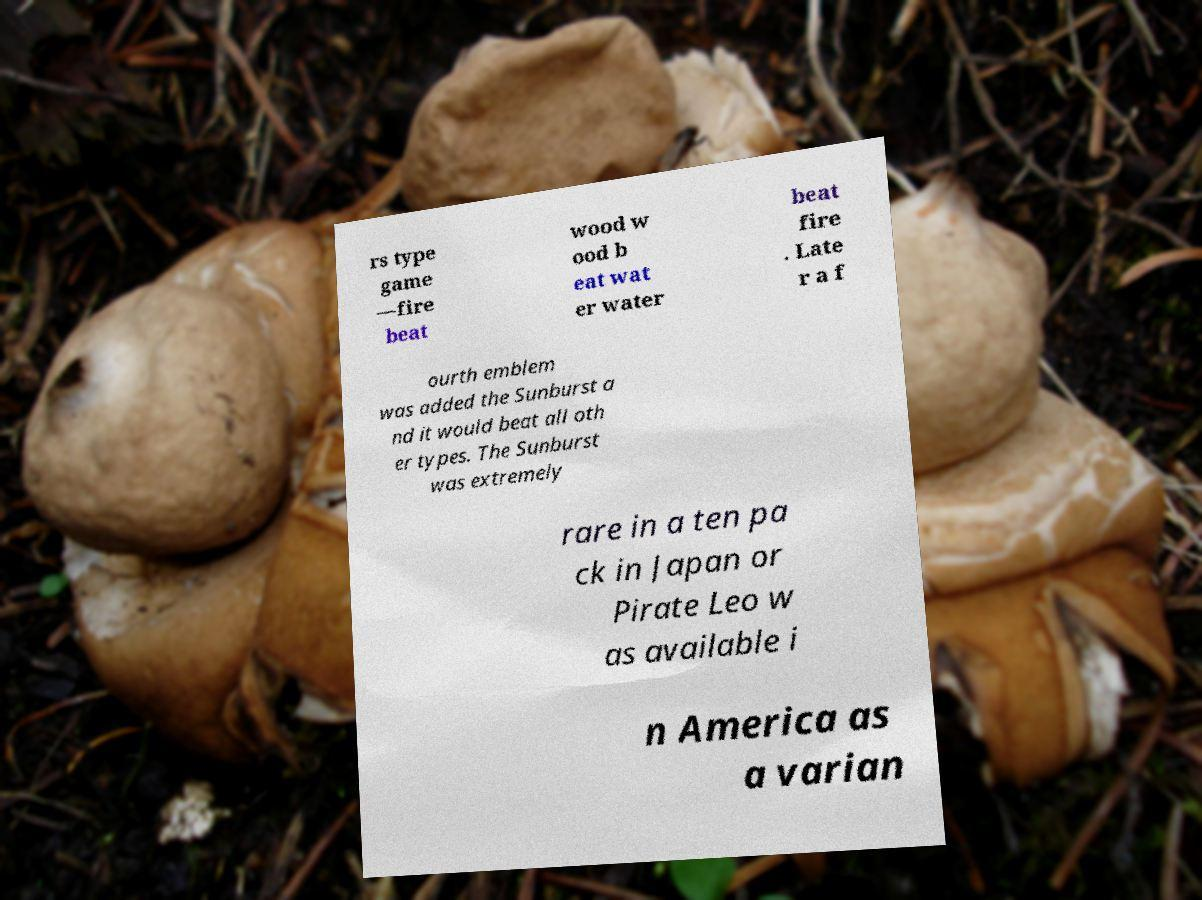There's text embedded in this image that I need extracted. Can you transcribe it verbatim? rs type game —fire beat wood w ood b eat wat er water beat fire . Late r a f ourth emblem was added the Sunburst a nd it would beat all oth er types. The Sunburst was extremely rare in a ten pa ck in Japan or Pirate Leo w as available i n America as a varian 